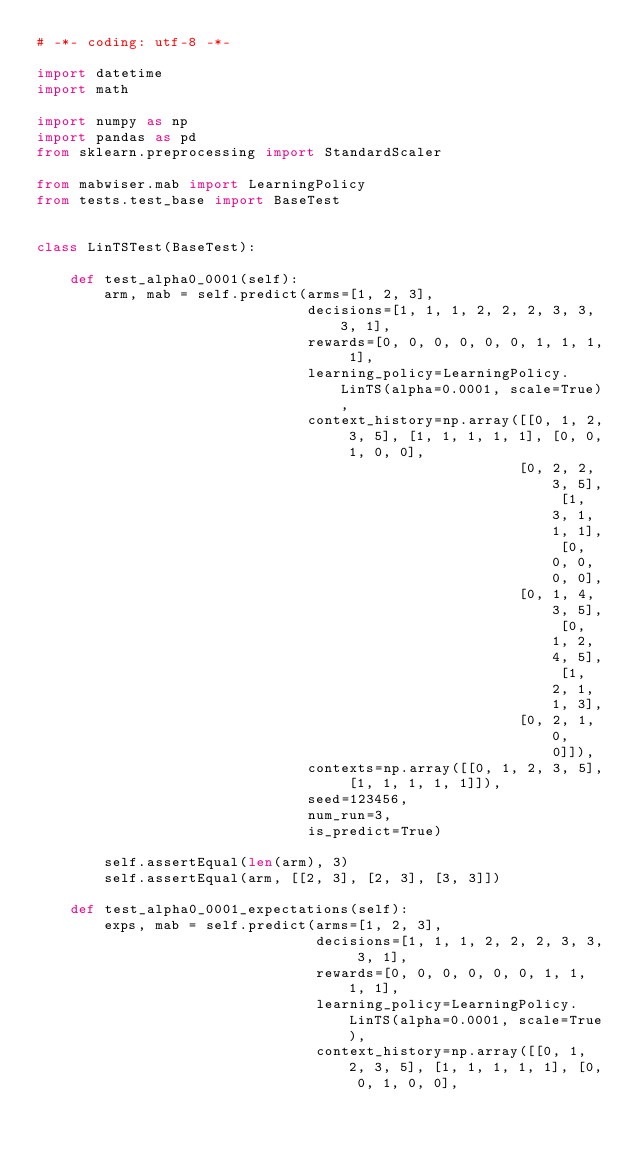<code> <loc_0><loc_0><loc_500><loc_500><_Python_># -*- coding: utf-8 -*-

import datetime
import math

import numpy as np
import pandas as pd
from sklearn.preprocessing import StandardScaler

from mabwiser.mab import LearningPolicy
from tests.test_base import BaseTest


class LinTSTest(BaseTest):

    def test_alpha0_0001(self):
        arm, mab = self.predict(arms=[1, 2, 3],
                                decisions=[1, 1, 1, 2, 2, 2, 3, 3, 3, 1],
                                rewards=[0, 0, 0, 0, 0, 0, 1, 1, 1, 1],
                                learning_policy=LearningPolicy.LinTS(alpha=0.0001, scale=True),
                                context_history=np.array([[0, 1, 2, 3, 5], [1, 1, 1, 1, 1], [0, 0, 1, 0, 0],
                                                         [0, 2, 2, 3, 5], [1, 3, 1, 1, 1], [0, 0, 0, 0, 0],
                                                         [0, 1, 4, 3, 5], [0, 1, 2, 4, 5], [1, 2, 1, 1, 3],
                                                         [0, 2, 1, 0, 0]]),
                                contexts=np.array([[0, 1, 2, 3, 5], [1, 1, 1, 1, 1]]),
                                seed=123456,
                                num_run=3,
                                is_predict=True)

        self.assertEqual(len(arm), 3)
        self.assertEqual(arm, [[2, 3], [2, 3], [3, 3]])

    def test_alpha0_0001_expectations(self):
        exps, mab = self.predict(arms=[1, 2, 3],
                                 decisions=[1, 1, 1, 2, 2, 2, 3, 3, 3, 1],
                                 rewards=[0, 0, 0, 0, 0, 0, 1, 1, 1, 1],
                                 learning_policy=LearningPolicy.LinTS(alpha=0.0001, scale=True),
                                 context_history=np.array([[0, 1, 2, 3, 5], [1, 1, 1, 1, 1], [0, 0, 1, 0, 0],</code> 